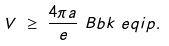<formula> <loc_0><loc_0><loc_500><loc_500>V & \ \geq \ \frac { 4 \pi a } { e } \ B b k \ e q i p { . }</formula> 